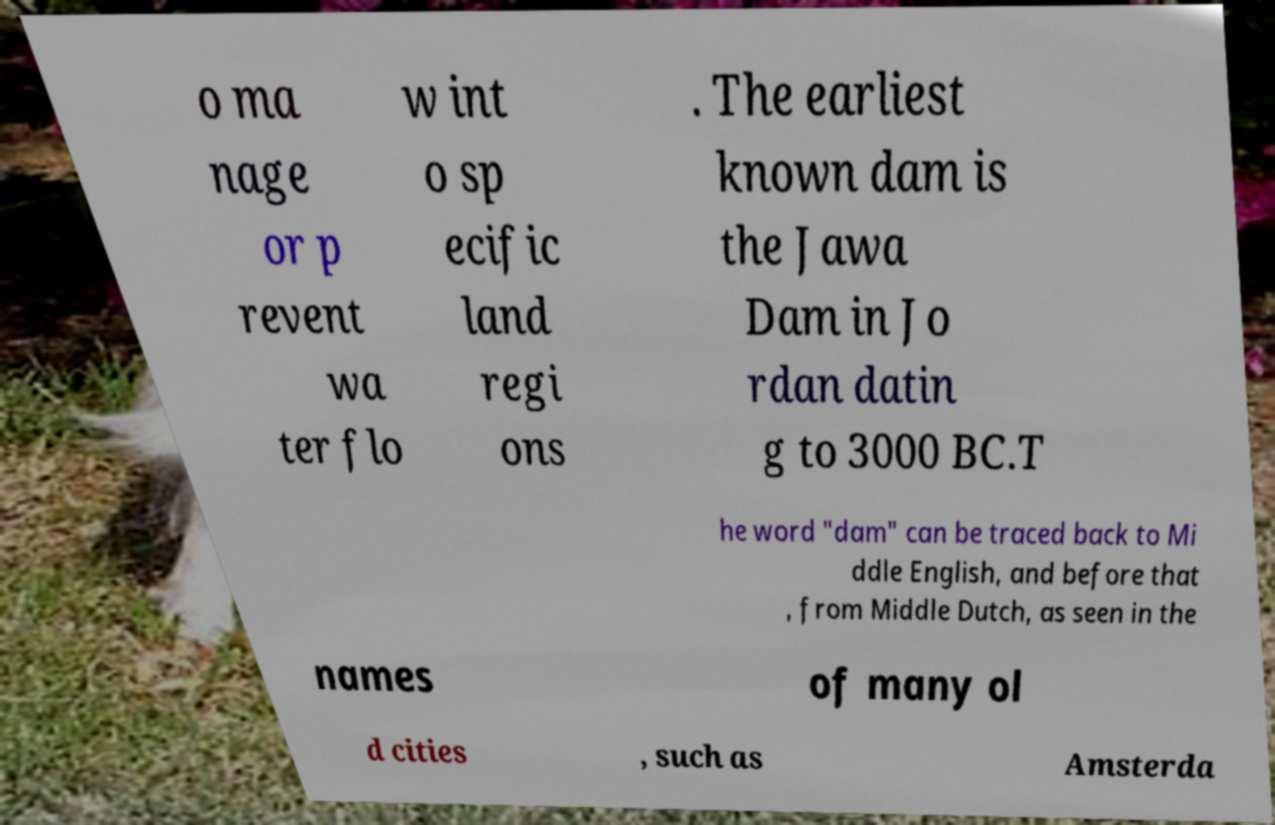Can you read and provide the text displayed in the image?This photo seems to have some interesting text. Can you extract and type it out for me? o ma nage or p revent wa ter flo w int o sp ecific land regi ons . The earliest known dam is the Jawa Dam in Jo rdan datin g to 3000 BC.T he word "dam" can be traced back to Mi ddle English, and before that , from Middle Dutch, as seen in the names of many ol d cities , such as Amsterda 